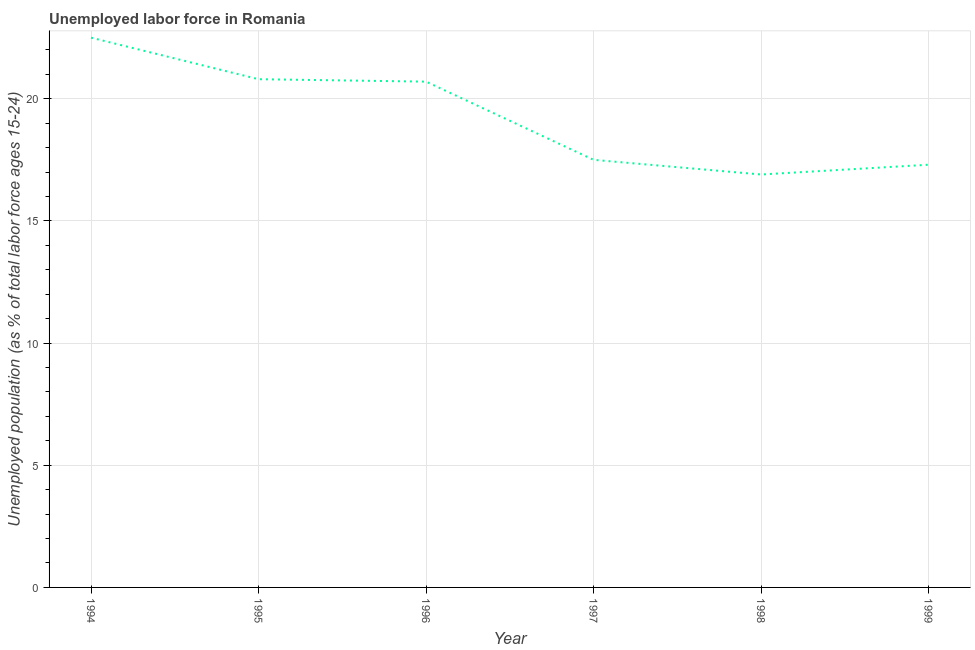What is the total unemployed youth population in 1999?
Your response must be concise. 17.3. Across all years, what is the maximum total unemployed youth population?
Ensure brevity in your answer.  22.5. Across all years, what is the minimum total unemployed youth population?
Provide a succinct answer. 16.9. In which year was the total unemployed youth population maximum?
Give a very brief answer. 1994. In which year was the total unemployed youth population minimum?
Offer a terse response. 1998. What is the sum of the total unemployed youth population?
Offer a terse response. 115.7. What is the difference between the total unemployed youth population in 1996 and 1997?
Keep it short and to the point. 3.2. What is the average total unemployed youth population per year?
Provide a succinct answer. 19.28. What is the median total unemployed youth population?
Your answer should be compact. 19.1. What is the ratio of the total unemployed youth population in 1998 to that in 1999?
Provide a succinct answer. 0.98. What is the difference between the highest and the second highest total unemployed youth population?
Give a very brief answer. 1.7. Is the sum of the total unemployed youth population in 1995 and 1999 greater than the maximum total unemployed youth population across all years?
Your answer should be very brief. Yes. What is the difference between the highest and the lowest total unemployed youth population?
Make the answer very short. 5.6. In how many years, is the total unemployed youth population greater than the average total unemployed youth population taken over all years?
Your answer should be very brief. 3. How many lines are there?
Offer a terse response. 1. How many years are there in the graph?
Offer a terse response. 6. Does the graph contain any zero values?
Make the answer very short. No. What is the title of the graph?
Provide a short and direct response. Unemployed labor force in Romania. What is the label or title of the X-axis?
Offer a terse response. Year. What is the label or title of the Y-axis?
Your answer should be very brief. Unemployed population (as % of total labor force ages 15-24). What is the Unemployed population (as % of total labor force ages 15-24) of 1995?
Ensure brevity in your answer.  20.8. What is the Unemployed population (as % of total labor force ages 15-24) of 1996?
Make the answer very short. 20.7. What is the Unemployed population (as % of total labor force ages 15-24) in 1998?
Provide a short and direct response. 16.9. What is the Unemployed population (as % of total labor force ages 15-24) in 1999?
Give a very brief answer. 17.3. What is the difference between the Unemployed population (as % of total labor force ages 15-24) in 1994 and 1995?
Make the answer very short. 1.7. What is the difference between the Unemployed population (as % of total labor force ages 15-24) in 1994 and 1996?
Ensure brevity in your answer.  1.8. What is the difference between the Unemployed population (as % of total labor force ages 15-24) in 1994 and 1997?
Your answer should be compact. 5. What is the difference between the Unemployed population (as % of total labor force ages 15-24) in 1994 and 1998?
Keep it short and to the point. 5.6. What is the difference between the Unemployed population (as % of total labor force ages 15-24) in 1995 and 1997?
Keep it short and to the point. 3.3. What is the difference between the Unemployed population (as % of total labor force ages 15-24) in 1997 and 1999?
Ensure brevity in your answer.  0.2. What is the ratio of the Unemployed population (as % of total labor force ages 15-24) in 1994 to that in 1995?
Offer a terse response. 1.08. What is the ratio of the Unemployed population (as % of total labor force ages 15-24) in 1994 to that in 1996?
Offer a very short reply. 1.09. What is the ratio of the Unemployed population (as % of total labor force ages 15-24) in 1994 to that in 1997?
Offer a very short reply. 1.29. What is the ratio of the Unemployed population (as % of total labor force ages 15-24) in 1994 to that in 1998?
Your response must be concise. 1.33. What is the ratio of the Unemployed population (as % of total labor force ages 15-24) in 1994 to that in 1999?
Give a very brief answer. 1.3. What is the ratio of the Unemployed population (as % of total labor force ages 15-24) in 1995 to that in 1997?
Ensure brevity in your answer.  1.19. What is the ratio of the Unemployed population (as % of total labor force ages 15-24) in 1995 to that in 1998?
Offer a very short reply. 1.23. What is the ratio of the Unemployed population (as % of total labor force ages 15-24) in 1995 to that in 1999?
Make the answer very short. 1.2. What is the ratio of the Unemployed population (as % of total labor force ages 15-24) in 1996 to that in 1997?
Ensure brevity in your answer.  1.18. What is the ratio of the Unemployed population (as % of total labor force ages 15-24) in 1996 to that in 1998?
Provide a succinct answer. 1.23. What is the ratio of the Unemployed population (as % of total labor force ages 15-24) in 1996 to that in 1999?
Provide a short and direct response. 1.2. What is the ratio of the Unemployed population (as % of total labor force ages 15-24) in 1997 to that in 1998?
Give a very brief answer. 1.04. What is the ratio of the Unemployed population (as % of total labor force ages 15-24) in 1997 to that in 1999?
Provide a succinct answer. 1.01. What is the ratio of the Unemployed population (as % of total labor force ages 15-24) in 1998 to that in 1999?
Offer a very short reply. 0.98. 